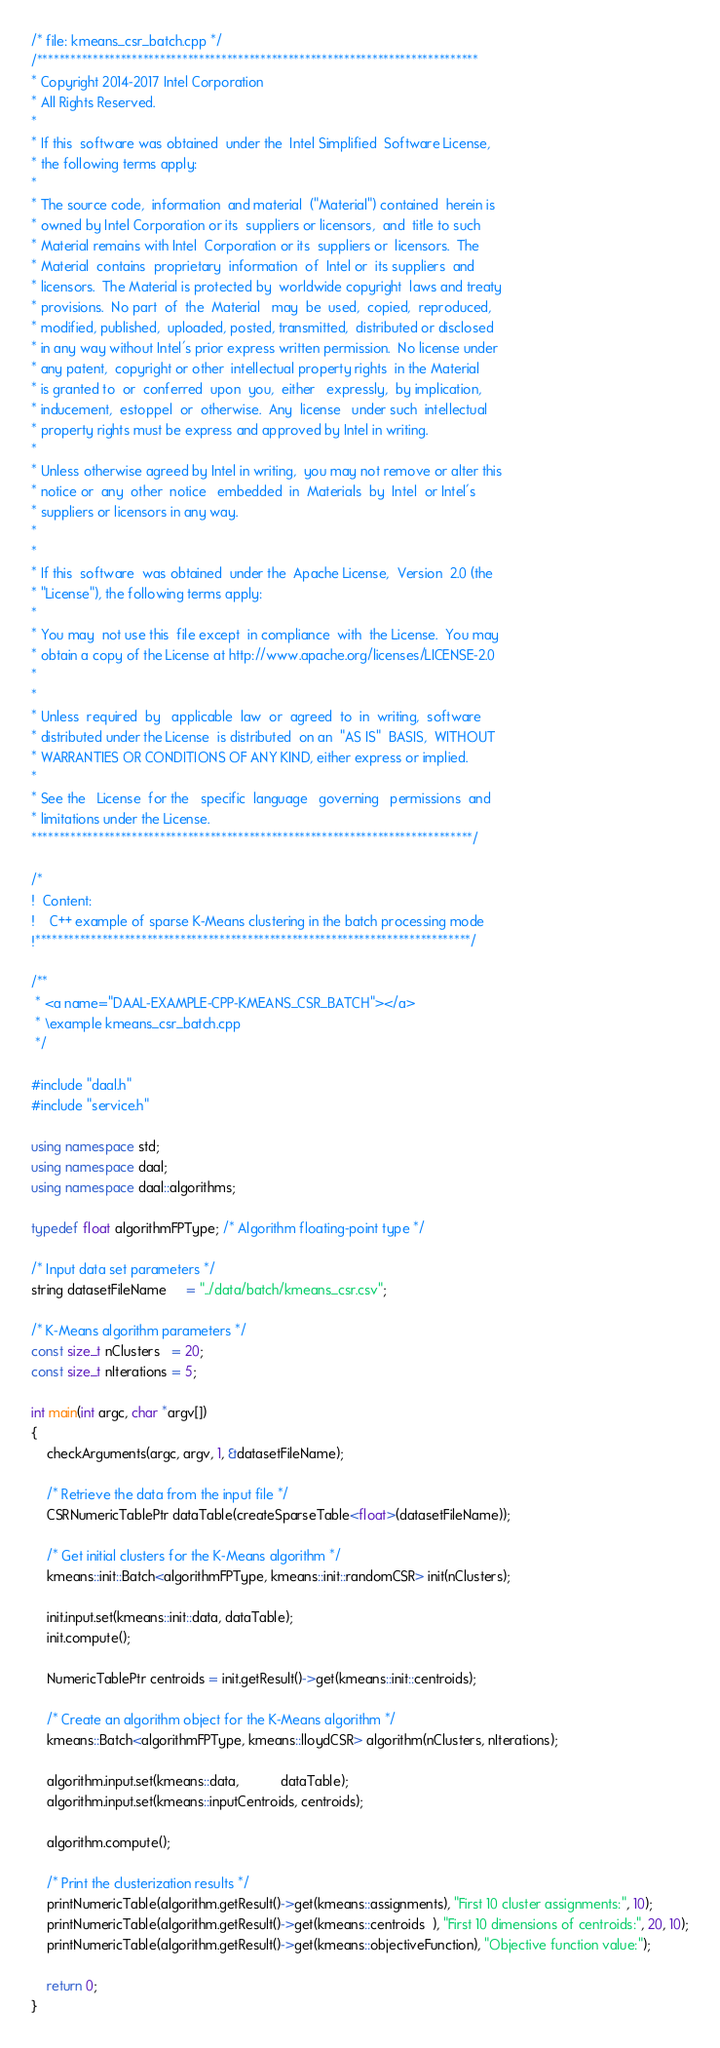Convert code to text. <code><loc_0><loc_0><loc_500><loc_500><_C++_>/* file: kmeans_csr_batch.cpp */
/*******************************************************************************
* Copyright 2014-2017 Intel Corporation
* All Rights Reserved.
*
* If this  software was obtained  under the  Intel Simplified  Software License,
* the following terms apply:
*
* The source code,  information  and material  ("Material") contained  herein is
* owned by Intel Corporation or its  suppliers or licensors,  and  title to such
* Material remains with Intel  Corporation or its  suppliers or  licensors.  The
* Material  contains  proprietary  information  of  Intel or  its suppliers  and
* licensors.  The Material is protected by  worldwide copyright  laws and treaty
* provisions.  No part  of  the  Material   may  be  used,  copied,  reproduced,
* modified, published,  uploaded, posted, transmitted,  distributed or disclosed
* in any way without Intel's prior express written permission.  No license under
* any patent,  copyright or other  intellectual property rights  in the Material
* is granted to  or  conferred  upon  you,  either   expressly,  by implication,
* inducement,  estoppel  or  otherwise.  Any  license   under such  intellectual
* property rights must be express and approved by Intel in writing.
*
* Unless otherwise agreed by Intel in writing,  you may not remove or alter this
* notice or  any  other  notice   embedded  in  Materials  by  Intel  or Intel's
* suppliers or licensors in any way.
*
*
* If this  software  was obtained  under the  Apache License,  Version  2.0 (the
* "License"), the following terms apply:
*
* You may  not use this  file except  in compliance  with  the License.  You may
* obtain a copy of the License at http://www.apache.org/licenses/LICENSE-2.0
*
*
* Unless  required  by   applicable  law  or  agreed  to  in  writing,  software
* distributed under the License  is distributed  on an  "AS IS"  BASIS,  WITHOUT
* WARRANTIES OR CONDITIONS OF ANY KIND, either express or implied.
*
* See the   License  for the   specific  language   governing   permissions  and
* limitations under the License.
*******************************************************************************/

/*
!  Content:
!    C++ example of sparse K-Means clustering in the batch processing mode
!******************************************************************************/

/**
 * <a name="DAAL-EXAMPLE-CPP-KMEANS_CSR_BATCH"></a>
 * \example kmeans_csr_batch.cpp
 */

#include "daal.h"
#include "service.h"

using namespace std;
using namespace daal;
using namespace daal::algorithms;

typedef float algorithmFPType; /* Algorithm floating-point type */

/* Input data set parameters */
string datasetFileName     = "../data/batch/kmeans_csr.csv";

/* K-Means algorithm parameters */
const size_t nClusters   = 20;
const size_t nIterations = 5;

int main(int argc, char *argv[])
{
    checkArguments(argc, argv, 1, &datasetFileName);

    /* Retrieve the data from the input file */
    CSRNumericTablePtr dataTable(createSparseTable<float>(datasetFileName));

    /* Get initial clusters for the K-Means algorithm */
    kmeans::init::Batch<algorithmFPType, kmeans::init::randomCSR> init(nClusters);

    init.input.set(kmeans::init::data, dataTable);
    init.compute();

    NumericTablePtr centroids = init.getResult()->get(kmeans::init::centroids);

    /* Create an algorithm object for the K-Means algorithm */
    kmeans::Batch<algorithmFPType, kmeans::lloydCSR> algorithm(nClusters, nIterations);

    algorithm.input.set(kmeans::data,           dataTable);
    algorithm.input.set(kmeans::inputCentroids, centroids);

    algorithm.compute();

    /* Print the clusterization results */
    printNumericTable(algorithm.getResult()->get(kmeans::assignments), "First 10 cluster assignments:", 10);
    printNumericTable(algorithm.getResult()->get(kmeans::centroids  ), "First 10 dimensions of centroids:", 20, 10);
    printNumericTable(algorithm.getResult()->get(kmeans::objectiveFunction), "Objective function value:");

    return 0;
}
</code> 